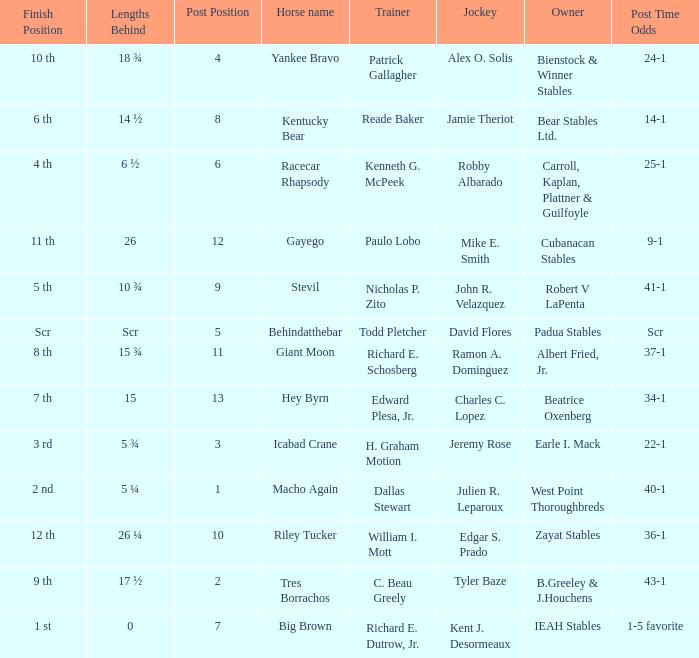Who was the jockey that had post time odds of 34-1? Charles C. Lopez. 